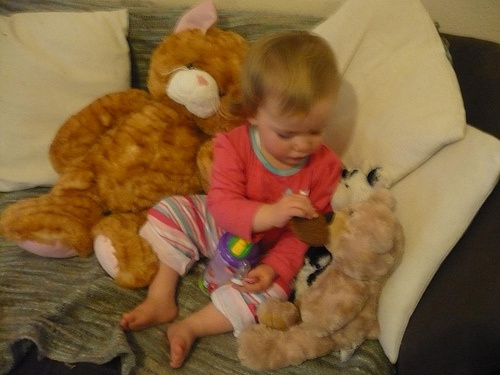Describe the objects in this image and their specific colors. I can see bed in tan, brown, olive, black, and maroon tones, couch in darkgreen, tan, black, and olive tones, people in darkgreen, brown, and maroon tones, teddy bear in darkgreen, brown, maroon, and tan tones, and teddy bear in darkgreen, olive, and tan tones in this image. 